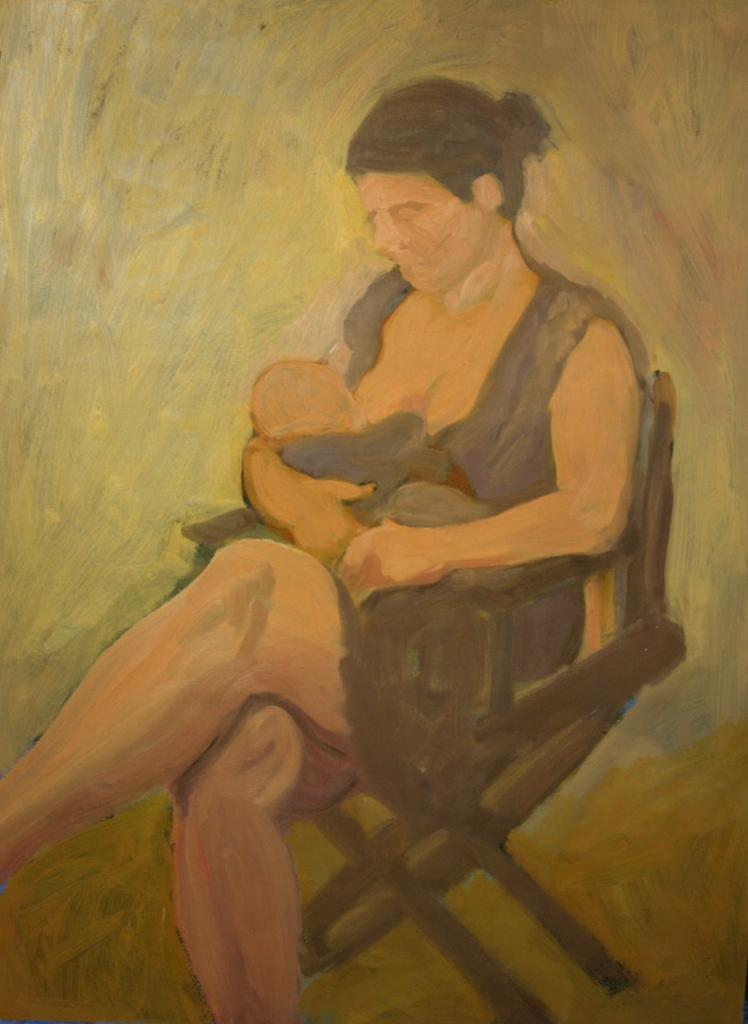What is the main subject of the image? There is a painting in the image. What is happening in the painting? The painting depicts a woman sitting on a chair and feeding a baby. Can you describe the setting of the painting? There might be a wall in the background of the painting. Where are the scissors located in the painting? There are no scissors present in the painting; it depicts a woman feeding a baby. What type of rod can be seen holding up the painting in the image? There is no rod visible in the image; it only shows the painting itself. 